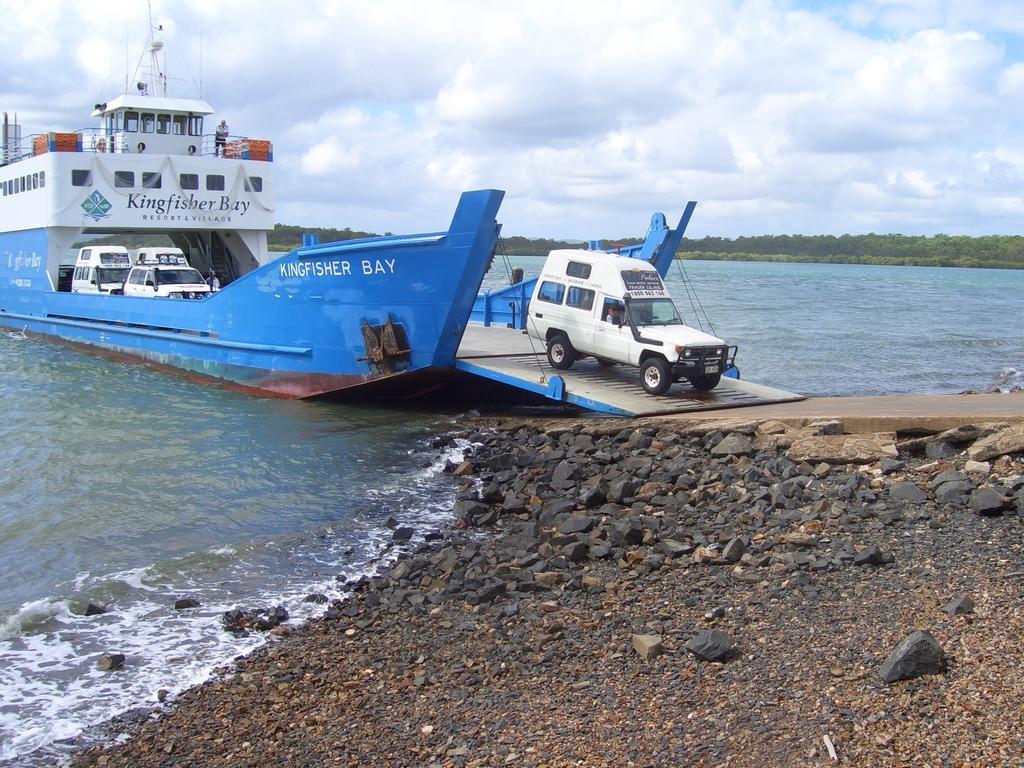In one or two sentences, can you explain what this image depicts? At the bottom of the image on the ground there are stones and also there is a slide. And there is water. On the water there is a ship with windows, railings, poles, vehicles and some other things. And also there are few names on it. In the background there are trees. At the top of the image there is sky with clouds. 